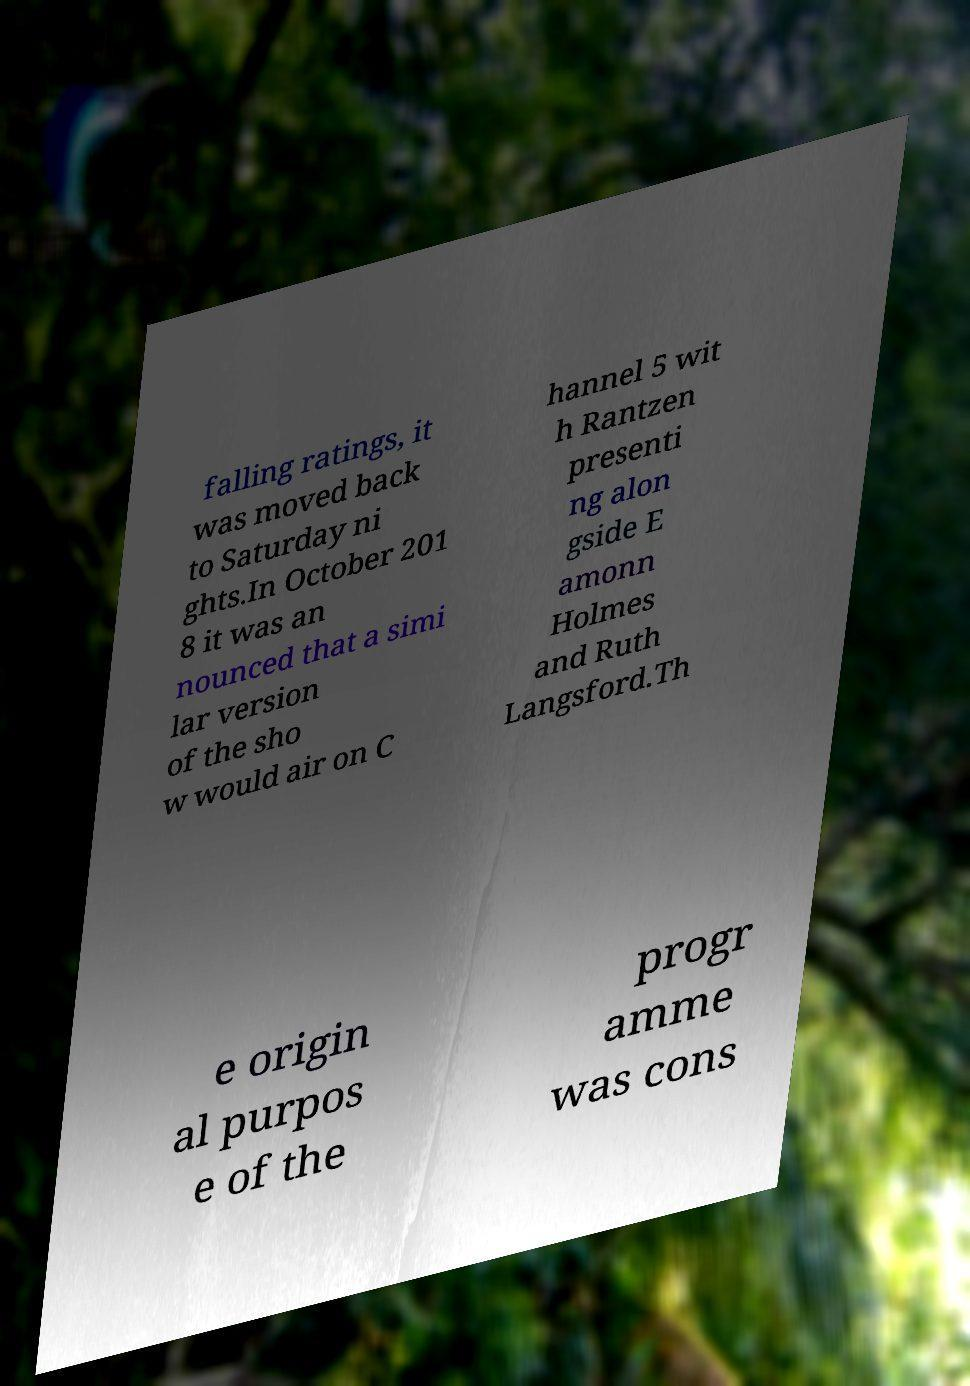Can you accurately transcribe the text from the provided image for me? falling ratings, it was moved back to Saturday ni ghts.In October 201 8 it was an nounced that a simi lar version of the sho w would air on C hannel 5 wit h Rantzen presenti ng alon gside E amonn Holmes and Ruth Langsford.Th e origin al purpos e of the progr amme was cons 